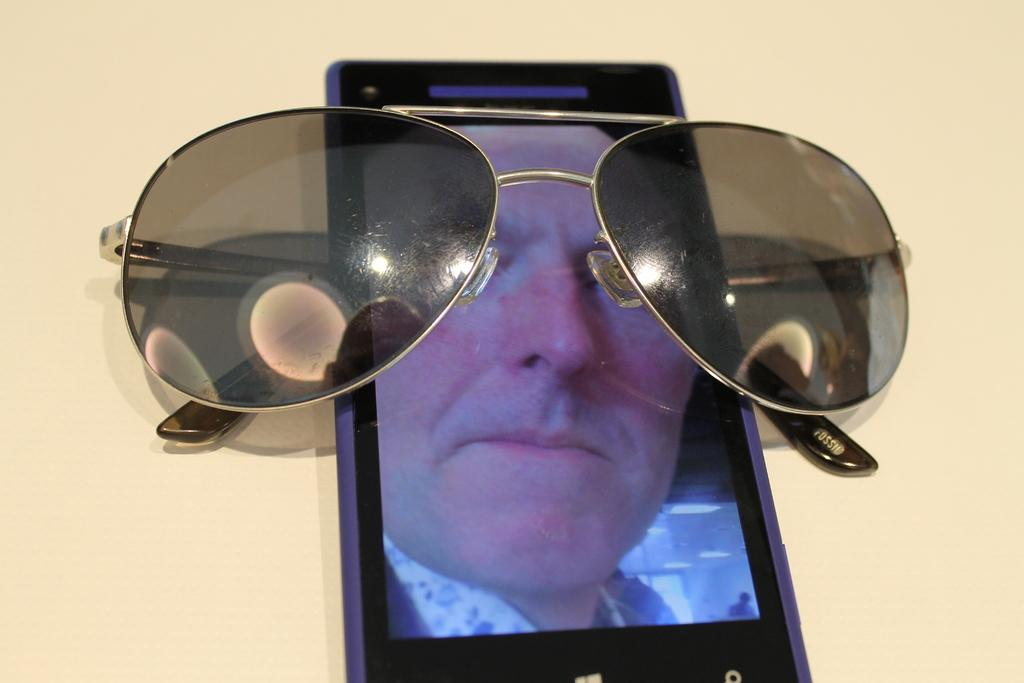What electronic device is visible in the image? There is a mobile phone in the image. What is displayed on the screen of the mobile phone? The mobile phone has a picture of a man on its screen. What type of object is placed on a surface in the image? There are glasses placed on a surface in the image. What type of cloth is being used to cover the mobile phone in the image? There is no cloth covering the mobile phone in the image; it is not mentioned in the provided facts. 